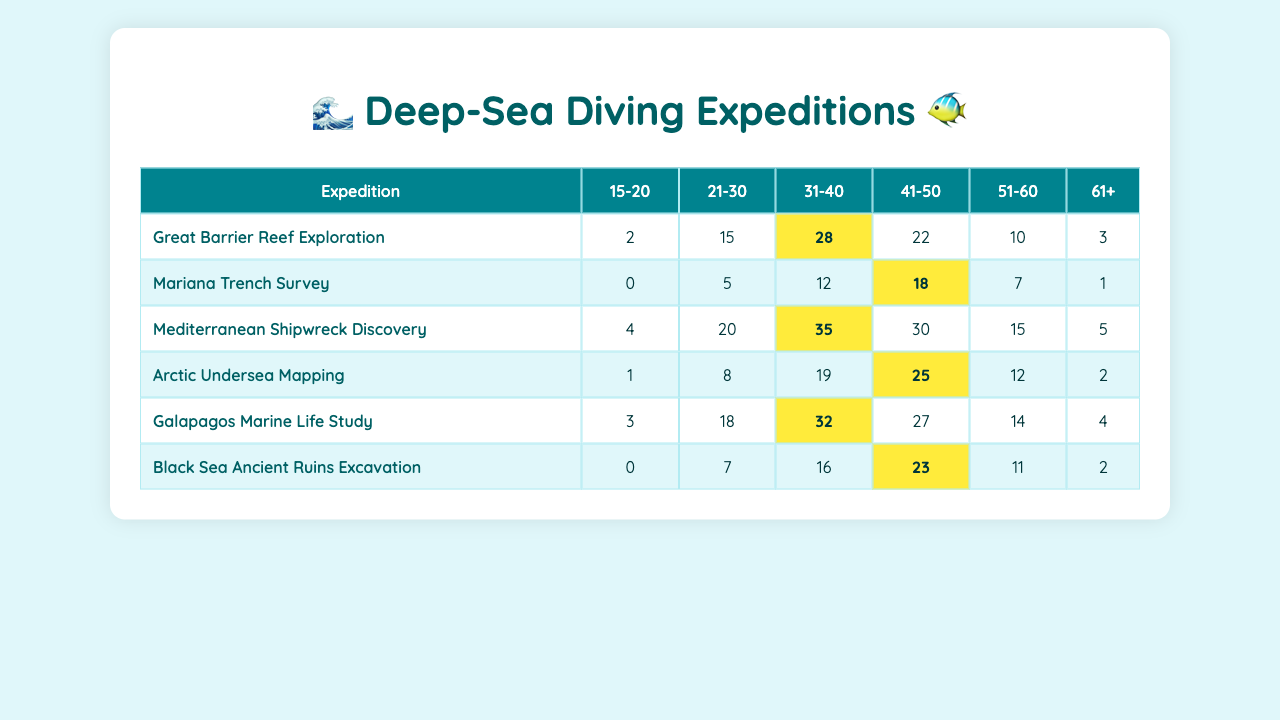What was the total number of successful dives for the Mediterranean Shipwreck Discovery expedition? To find the total successful dives, we look at the corresponding values in the table for the Mediterranean Shipwreck Discovery expedition: 4, 20, 35, 30, 15, and 5. We add these numbers together: 4 + 20 + 35 + 30 + 15 + 5 = 109.
Answer: 109 Which age group had the most successful dives in the Great Barrier Reef Exploration? For the Great Barrier Reef Exploration, the successful dives by age group are: 2, 15, 28, 22, 10, and 3. The maximum is 28, which corresponds to the age group 31-40.
Answer: 31-40 Did the 61+ age group have more successful dives in the Arctic Undersea Mapping than the Black Sea Ancient Ruins Excavation? For the Arctic Undersea Mapping, the 61+ age group had 2 successful dives, while for the Black Sea Ancient Ruins Excavation, the 61+ age group had 2 successful dives as well. Since 2 is equal to 2, we conclude that the 61+ age group did not have more dives in either expedition.
Answer: No What is the average number of successful dives for the age group 21-30 across all expeditions? We first sum the successful dives for the 21-30 age group from all expeditions: 15 (Great Barrier Reef) + 5 (Mariana Trench) + 20 (Mediterranean Shipwreck) + 8 (Arctic Mapping) + 18 (Galapagos Study) + 7 (Black Sea Excavation) = 73. There are 6 expeditions, so the average is 73 divided by 6, which gives us approximately 12.17.
Answer: 12.17 Which expedition had the highest number of successful dives in the 41-50 age group? Looking at the values for the 41-50 age group across expeditions: 22 (Great Barrier Reef), 18 (Mariana Trench), 30 (Mediterranean Shipwreck), 25 (Arctic Mapping), 27 (Galapagos Study), and 23 (Black Sea). The highest value is 30, which belongs to the Mediterranean Shipwreck Discovery.
Answer: Mediterranean Shipwreck Discovery What is the difference in successful dives for the 31-40 age group between the Galapagos Marine Life Study and the Black Sea Ancient Ruins Excavation? The successful dives for the Galapagos Marine Life Study in the 31-40 age group is 32, while for the Black Sea Ancient Ruins Excavation, it is 16. The difference is calculated as 32 - 16 = 16.
Answer: 16 Was there any expedition where the 15-20 age group had successful dives that were higher than the 61+ age group? The successful dives for the 15-20 age group are: 2 (Great Barrier Reef), 0 (Mariana Trench), 4 (Mediterranean Shipwreck), 1 (Arctic Mapping), 3 (Galapagos Study), and 0 (Black Sea). The successful dives for the 61+ age group are: 3 (Great Barrier Reef), 1 (Mariana Trench), 5 (Mediterranean Shipwreck), 2 (Arctic Mapping), 4 (Galapagos Study), and 2 (Black Sea). Since the maximum for the 15-20 age group is 4 and the maximum for the 61+ age group is 5, the 15-20 age group does not have any higher successful dives than the 61+.
Answer: No Which age group has the least total successful dives across all expeditions? We need to sum the successful dives for each age group: 15-20 = 10, 21-30 = 73, 31-40 = 160, 41-50 = 125, 51-60 = 61, 61+ = 15. The least total successful dives is for the 15-20 age group with 10 successful dives.
Answer: 15-20 